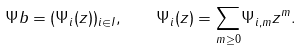<formula> <loc_0><loc_0><loc_500><loc_500>\Psi b = ( \Psi _ { i } ( z ) ) _ { i \in I } , \quad \Psi _ { i } ( z ) = \underset { m \geq 0 } { \sum } \Psi _ { i , m } z ^ { m } .</formula> 